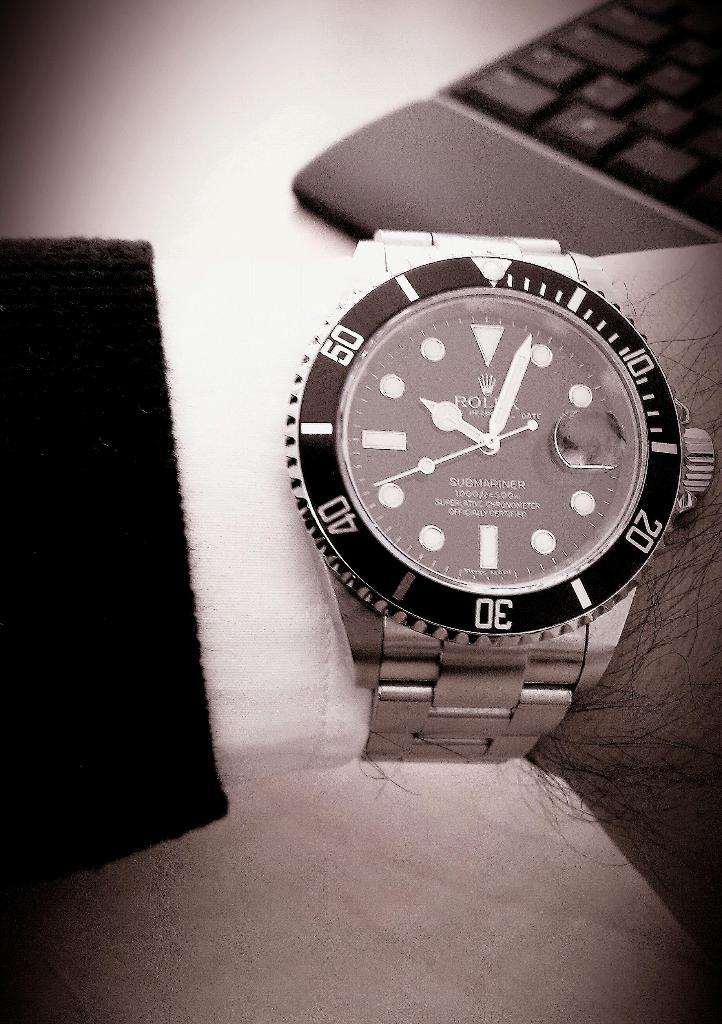<image>
Write a terse but informative summary of the picture. A Rolex watch called the Submariner is being displayed on someone's wrist. 